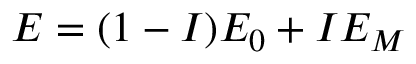Convert formula to latex. <formula><loc_0><loc_0><loc_500><loc_500>E = ( 1 - I ) E _ { 0 } + I E _ { M }</formula> 